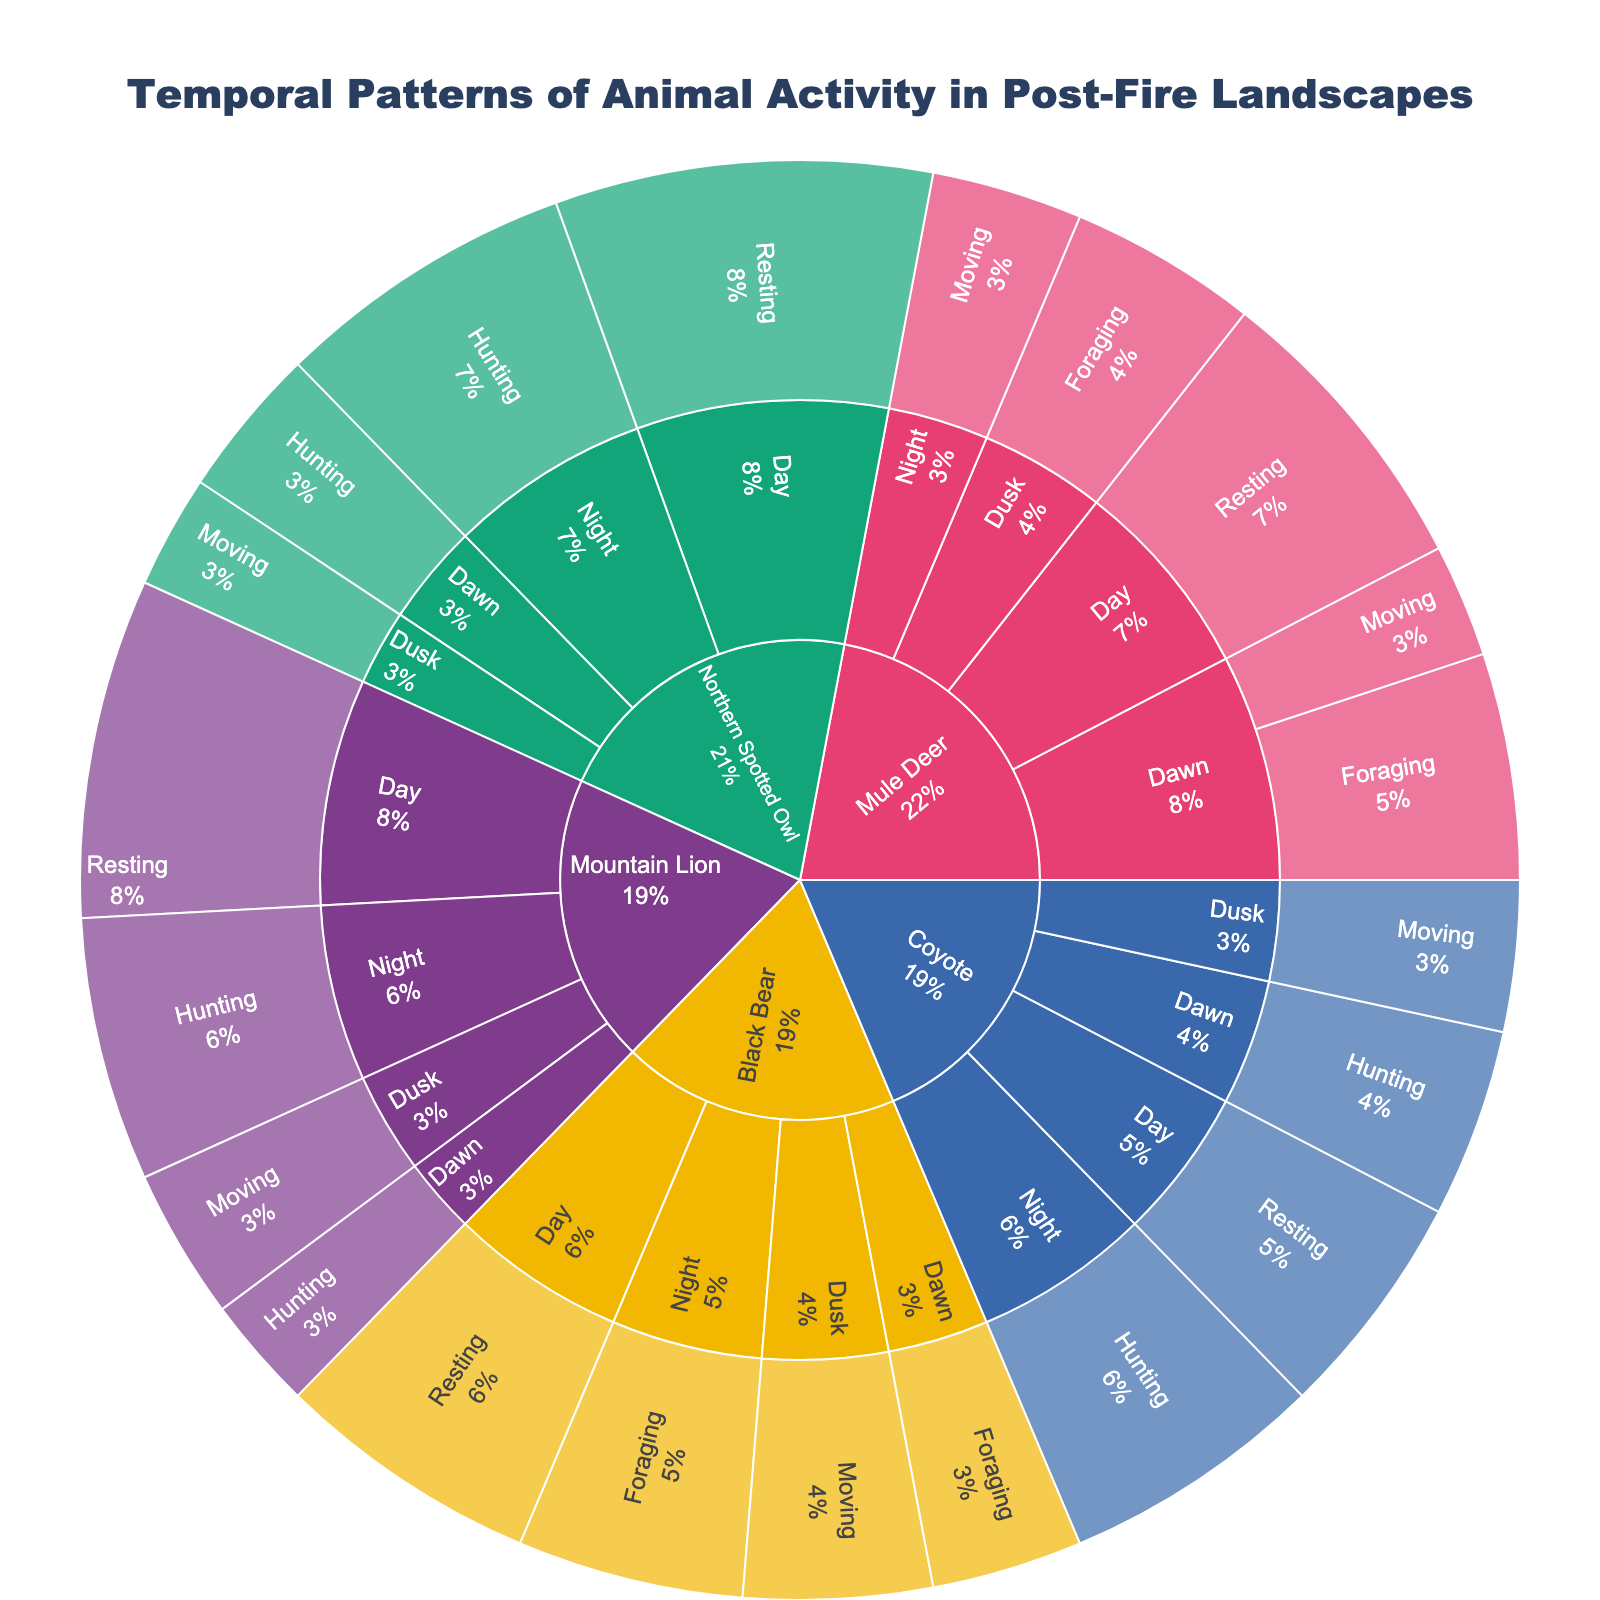What's the total activity value for the Mule Deer at Dawn? To find the total activity value for Mule Deer at Dawn, sum up the values for Foraging and Moving: 30 (Foraging) + 15 (Moving) = 45.
Answer: 45 Which species has the highest value for resting during the day? Look at the resting values for all species during the day and compare them. Mule Deer has 40, Black Bear has 35, Mountain Lion has 45, Coyote has 30, and Northern Spotted Owl has 50. The highest value is 50 for Northern Spotted Owl.
Answer: Northern Spotted Owl What is the main activity for Black Bears at Night? In the Sunburst, check the segment for Black Bears at Night and identify the activity with the highest value. Foraging has a value of 30.
Answer: Foraging Compare the total activity values for Mountain Lion and Coyote at Night. Which one is higher? Sum the values for all activities for both species at Night: Mountain Lion (Hunting: 35) = 35, Coyote (Hunting: 35) = 35. Both have the same value.
Answer: Equal What's the most common activity for the Northern Spotted Owl at Dusk? Look at the activities for the Northern Spotted Owl at Dusk and compare their values. Moving has a value of 15.
Answer: Moving What's the total activity value for all species at Dawn? Sum up all activity values at Dawn for each species: Mule Deer (30 + 15) = 45, Black Bear (20), Mountain Lion (15), Coyote (25), Northern Spotted Owl (20). Total = 45 + 20 + 15 + 25 + 20 = 125.
Answer: 125 How does the value of Hunting at Night compare between Mountain Lion and Northern Spotted Owl? Compare the values for Hunting at Night: Mountain Lion has 35, Northern Spotted Owl has 40. The value for Northern Spotted Owl is higher.
Answer: Northern Spotted Owl Which time of day has the highest total activity value for the Black Bear? Sum the total activity values for each time of day for Black Bear: Dawn (20), Day (35), Dusk (25), Night (30). The highest is during the Day (35).
Answer: Day What percentage of the Coyote's total activity occurs at Night? Calculate total activity values for Coyote at Night and for all times of day: Night (35), Dawn (25), Day (30), Dusk (20). Total = 110, so percent at Night = (35/110) * 100 ≈ 31.82%.
Answer: ~31.82% How does the Mule Deer’s foraging activity at Dusk compare to its foraging activity at Dawn? Compare the values for foraging activity: Dusk (25), Dawn (30). The value is higher at Dawn.
Answer: Dawn 